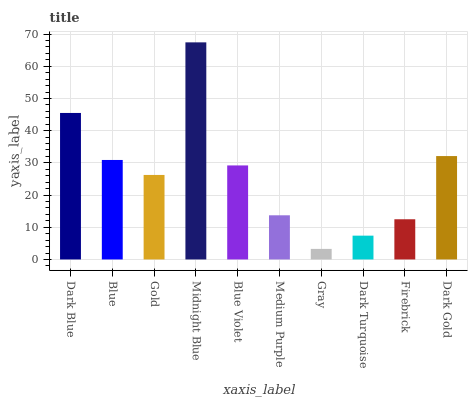Is Gray the minimum?
Answer yes or no. Yes. Is Midnight Blue the maximum?
Answer yes or no. Yes. Is Blue the minimum?
Answer yes or no. No. Is Blue the maximum?
Answer yes or no. No. Is Dark Blue greater than Blue?
Answer yes or no. Yes. Is Blue less than Dark Blue?
Answer yes or no. Yes. Is Blue greater than Dark Blue?
Answer yes or no. No. Is Dark Blue less than Blue?
Answer yes or no. No. Is Blue Violet the high median?
Answer yes or no. Yes. Is Gold the low median?
Answer yes or no. Yes. Is Midnight Blue the high median?
Answer yes or no. No. Is Blue Violet the low median?
Answer yes or no. No. 